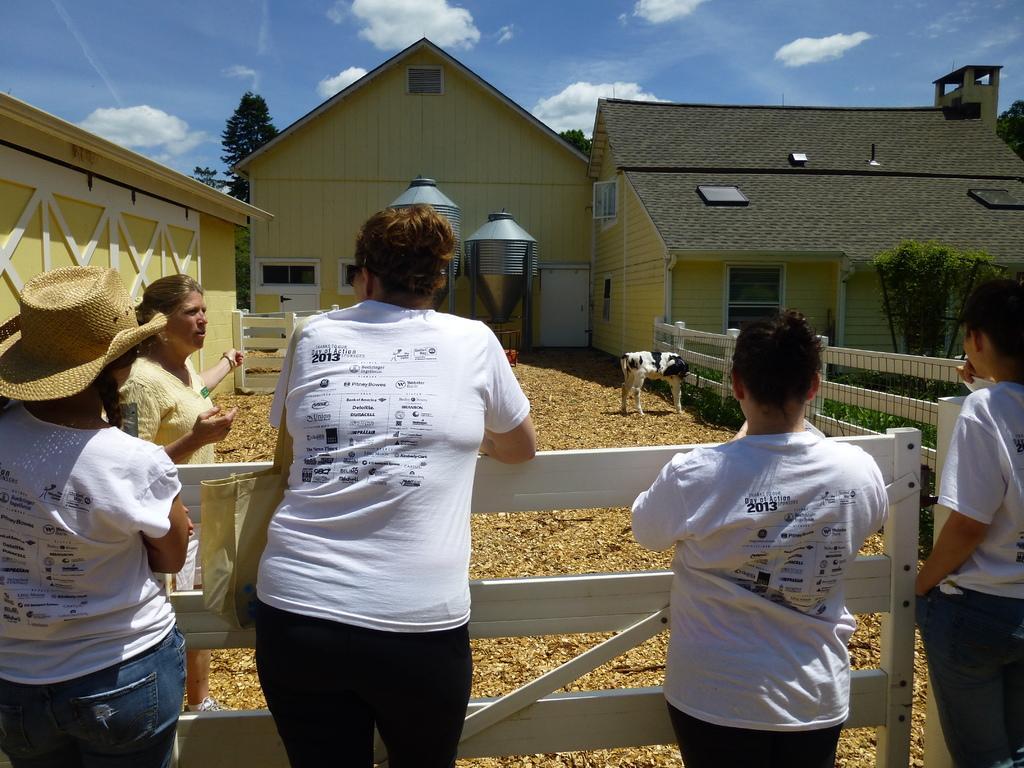Can you describe this image briefly? In this image there are buildings and there is a goat, around the goat there is a wooden fence, in front of the fence there are a few people standing, in front of the buildings there are trees. In the background there is the sky. 